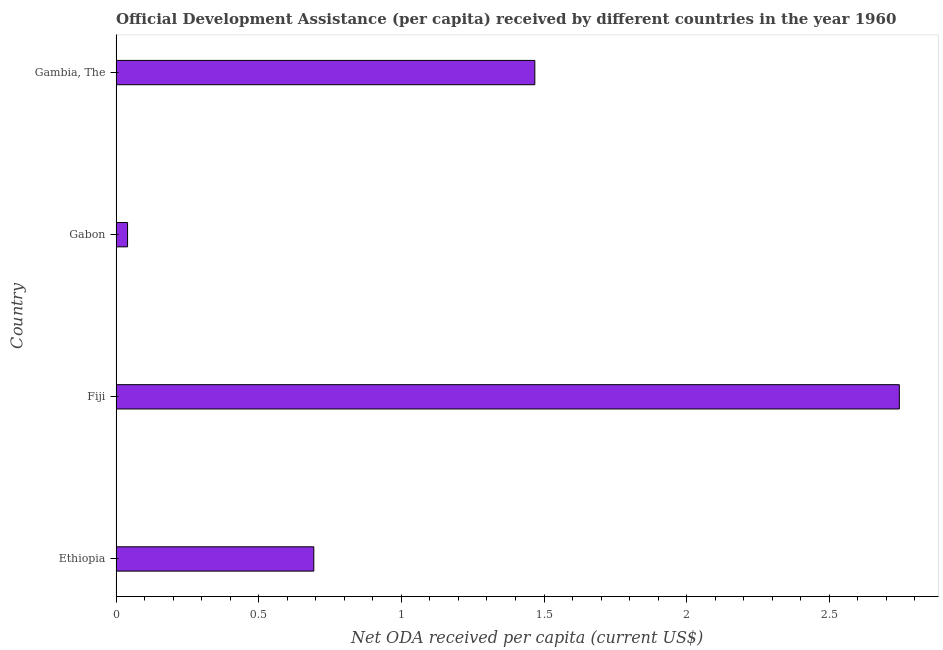What is the title of the graph?
Your answer should be compact. Official Development Assistance (per capita) received by different countries in the year 1960. What is the label or title of the X-axis?
Ensure brevity in your answer.  Net ODA received per capita (current US$). What is the net oda received per capita in Gambia, The?
Provide a short and direct response. 1.47. Across all countries, what is the maximum net oda received per capita?
Make the answer very short. 2.75. Across all countries, what is the minimum net oda received per capita?
Ensure brevity in your answer.  0.04. In which country was the net oda received per capita maximum?
Your answer should be very brief. Fiji. In which country was the net oda received per capita minimum?
Provide a short and direct response. Gabon. What is the sum of the net oda received per capita?
Provide a succinct answer. 4.95. What is the difference between the net oda received per capita in Gabon and Gambia, The?
Your response must be concise. -1.43. What is the average net oda received per capita per country?
Provide a short and direct response. 1.24. What is the median net oda received per capita?
Give a very brief answer. 1.08. What is the ratio of the net oda received per capita in Ethiopia to that in Gabon?
Your answer should be very brief. 17.3. Is the difference between the net oda received per capita in Ethiopia and Fiji greater than the difference between any two countries?
Keep it short and to the point. No. What is the difference between the highest and the second highest net oda received per capita?
Ensure brevity in your answer.  1.28. Is the sum of the net oda received per capita in Fiji and Gambia, The greater than the maximum net oda received per capita across all countries?
Provide a short and direct response. Yes. What is the difference between the highest and the lowest net oda received per capita?
Your answer should be very brief. 2.71. In how many countries, is the net oda received per capita greater than the average net oda received per capita taken over all countries?
Ensure brevity in your answer.  2. How many bars are there?
Offer a very short reply. 4. How many countries are there in the graph?
Ensure brevity in your answer.  4. What is the Net ODA received per capita (current US$) of Ethiopia?
Your response must be concise. 0.69. What is the Net ODA received per capita (current US$) of Fiji?
Provide a succinct answer. 2.75. What is the Net ODA received per capita (current US$) in Gabon?
Give a very brief answer. 0.04. What is the Net ODA received per capita (current US$) of Gambia, The?
Provide a short and direct response. 1.47. What is the difference between the Net ODA received per capita (current US$) in Ethiopia and Fiji?
Your response must be concise. -2.05. What is the difference between the Net ODA received per capita (current US$) in Ethiopia and Gabon?
Provide a succinct answer. 0.65. What is the difference between the Net ODA received per capita (current US$) in Ethiopia and Gambia, The?
Ensure brevity in your answer.  -0.77. What is the difference between the Net ODA received per capita (current US$) in Fiji and Gabon?
Provide a succinct answer. 2.71. What is the difference between the Net ODA received per capita (current US$) in Fiji and Gambia, The?
Give a very brief answer. 1.28. What is the difference between the Net ODA received per capita (current US$) in Gabon and Gambia, The?
Offer a terse response. -1.43. What is the ratio of the Net ODA received per capita (current US$) in Ethiopia to that in Fiji?
Your response must be concise. 0.25. What is the ratio of the Net ODA received per capita (current US$) in Ethiopia to that in Gabon?
Your answer should be very brief. 17.3. What is the ratio of the Net ODA received per capita (current US$) in Ethiopia to that in Gambia, The?
Make the answer very short. 0.47. What is the ratio of the Net ODA received per capita (current US$) in Fiji to that in Gabon?
Make the answer very short. 68.52. What is the ratio of the Net ODA received per capita (current US$) in Fiji to that in Gambia, The?
Your answer should be very brief. 1.87. What is the ratio of the Net ODA received per capita (current US$) in Gabon to that in Gambia, The?
Keep it short and to the point. 0.03. 